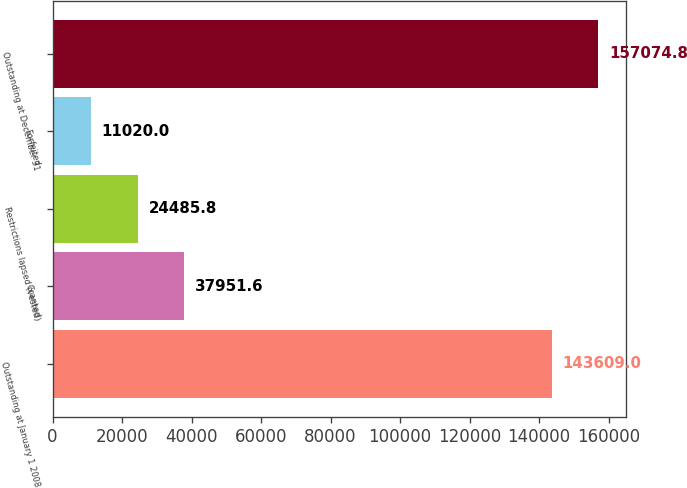<chart> <loc_0><loc_0><loc_500><loc_500><bar_chart><fcel>Outstanding at January 1 2008<fcel>Granted<fcel>Restrictions lapsed (vested)<fcel>Forfeited<fcel>Outstanding at December 31<nl><fcel>143609<fcel>37951.6<fcel>24485.8<fcel>11020<fcel>157075<nl></chart> 